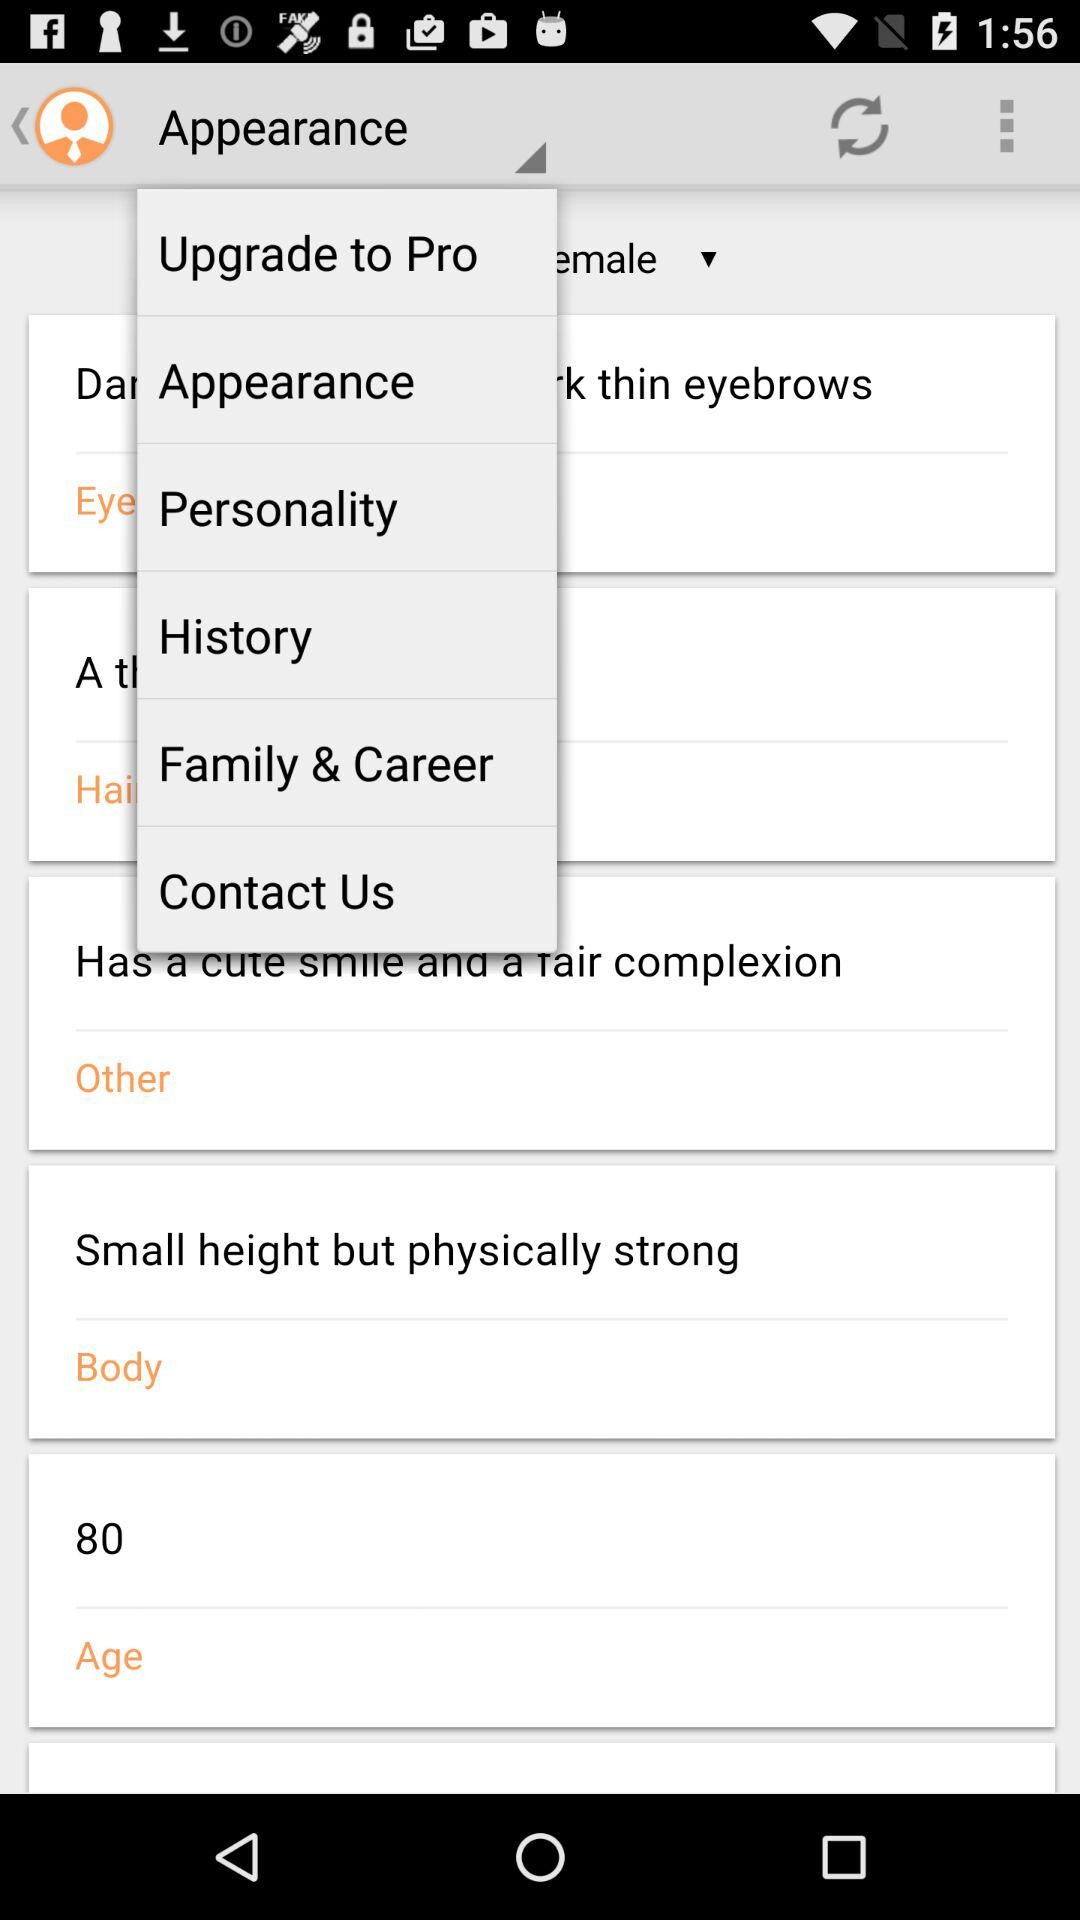What is the body structure? The body structure is "Small height but physically strong". 